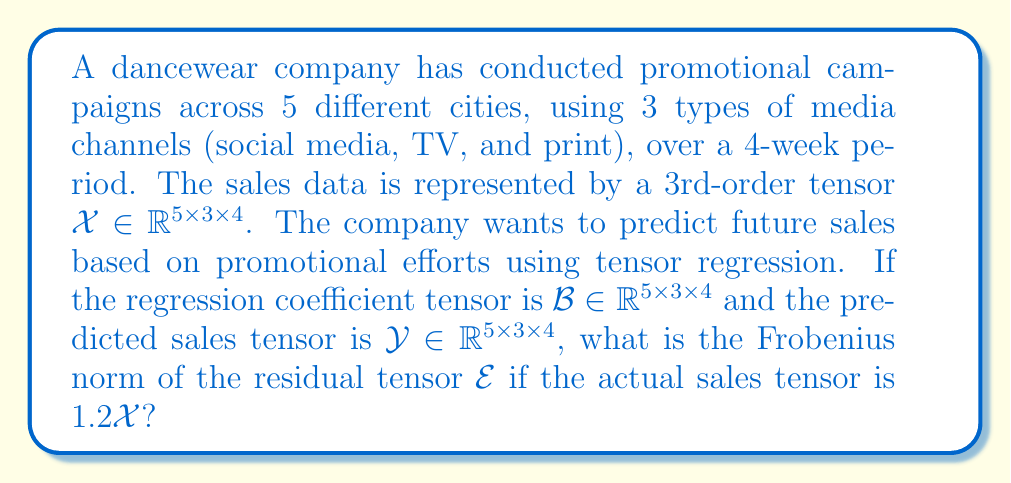Teach me how to tackle this problem. To solve this problem, we need to follow these steps:

1) In tensor regression, the model can be expressed as:
   $$\mathcal{Y} = \langle \mathcal{X}, \mathcal{B} \rangle + \mathcal{E}$$
   where $\langle \cdot, \cdot \rangle$ denotes the tensor contraction.

2) We're given that the actual sales tensor is $1.2\mathcal{X}$. Let's call this $\mathcal{Y}_{actual}$. So:
   $$\mathcal{Y}_{actual} = 1.2\mathcal{X}$$

3) The residual tensor $\mathcal{E}$ is the difference between the actual and predicted sales:
   $$\mathcal{E} = \mathcal{Y}_{actual} - \mathcal{Y}$$

4) Substituting the expressions:
   $$\mathcal{E} = 1.2\mathcal{X} - \langle \mathcal{X}, \mathcal{B} \rangle$$

5) The Frobenius norm of a tensor is the square root of the sum of the squares of its elements. For our residual tensor:
   $$\|\mathcal{E}\|_F = \sqrt{\sum_{i=1}^5 \sum_{j=1}^3 \sum_{k=1}^4 (1.2x_{ijk} - y_{ijk})^2}$$
   where $x_{ijk}$ and $y_{ijk}$ are elements of $\mathcal{X}$ and $\mathcal{Y}$ respectively.

6) Without knowing the specific values in $\mathcal{X}$ and $\mathcal{B}$, we can't calculate the exact value. However, we can express it in terms of the norms of $\mathcal{X}$ and $\langle \mathcal{X}, \mathcal{B} \rangle$:
   $$\|\mathcal{E}\|_F = \sqrt{\|1.2\mathcal{X}\|_F^2 + \|\langle \mathcal{X}, \mathcal{B} \rangle\|_F^2 - 2.4\langle \mathcal{X}, \langle \mathcal{X}, \mathcal{B} \rangle \rangle}$$

7) This can be simplified to:
   $$\|\mathcal{E}\|_F = \sqrt{1.44\|\mathcal{X}\|_F^2 + \|\langle \mathcal{X}, \mathcal{B} \rangle\|_F^2 - 2.4\langle \mathcal{X}, \langle \mathcal{X}, \mathcal{B} \rangle \rangle}$$
Answer: $$\sqrt{1.44\|\mathcal{X}\|_F^2 + \|\langle \mathcal{X}, \mathcal{B} \rangle\|_F^2 - 2.4\langle \mathcal{X}, \langle \mathcal{X}, \mathcal{B} \rangle \rangle}$$ 